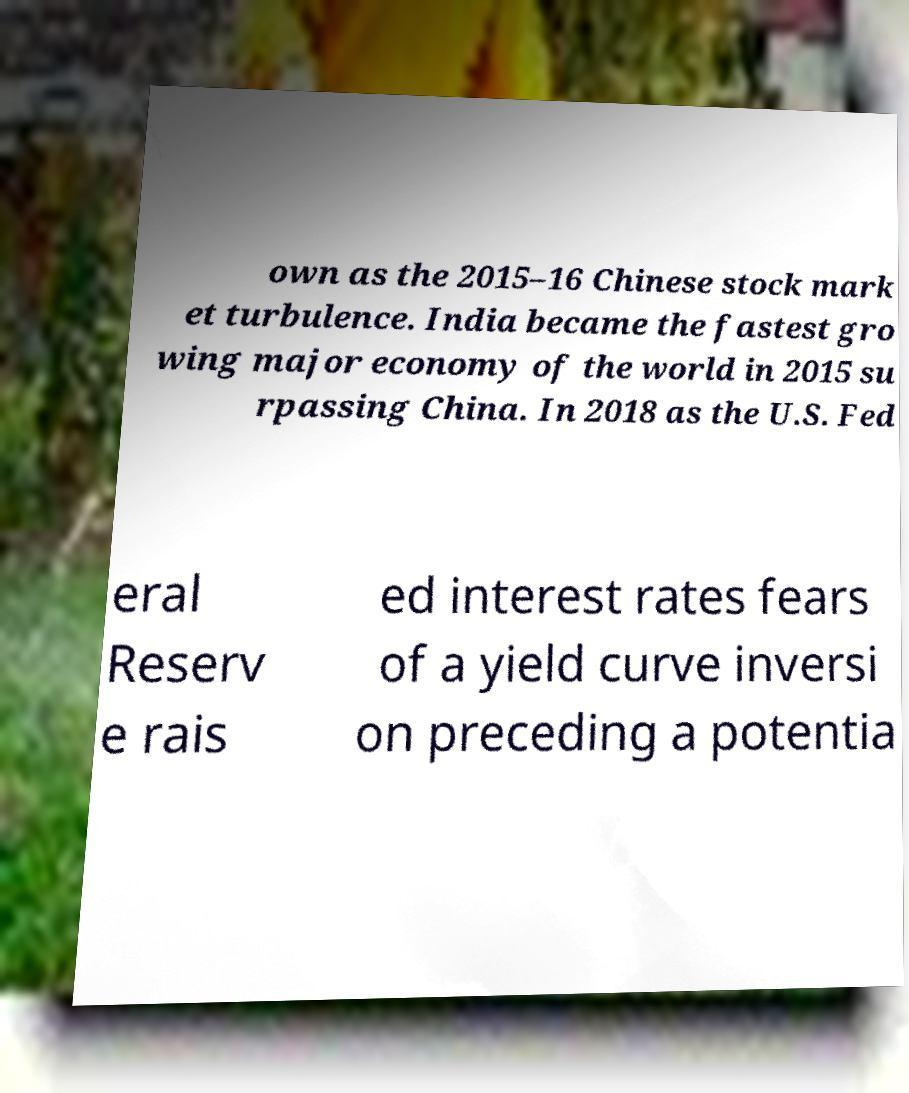I need the written content from this picture converted into text. Can you do that? own as the 2015–16 Chinese stock mark et turbulence. India became the fastest gro wing major economy of the world in 2015 su rpassing China. In 2018 as the U.S. Fed eral Reserv e rais ed interest rates fears of a yield curve inversi on preceding a potentia 